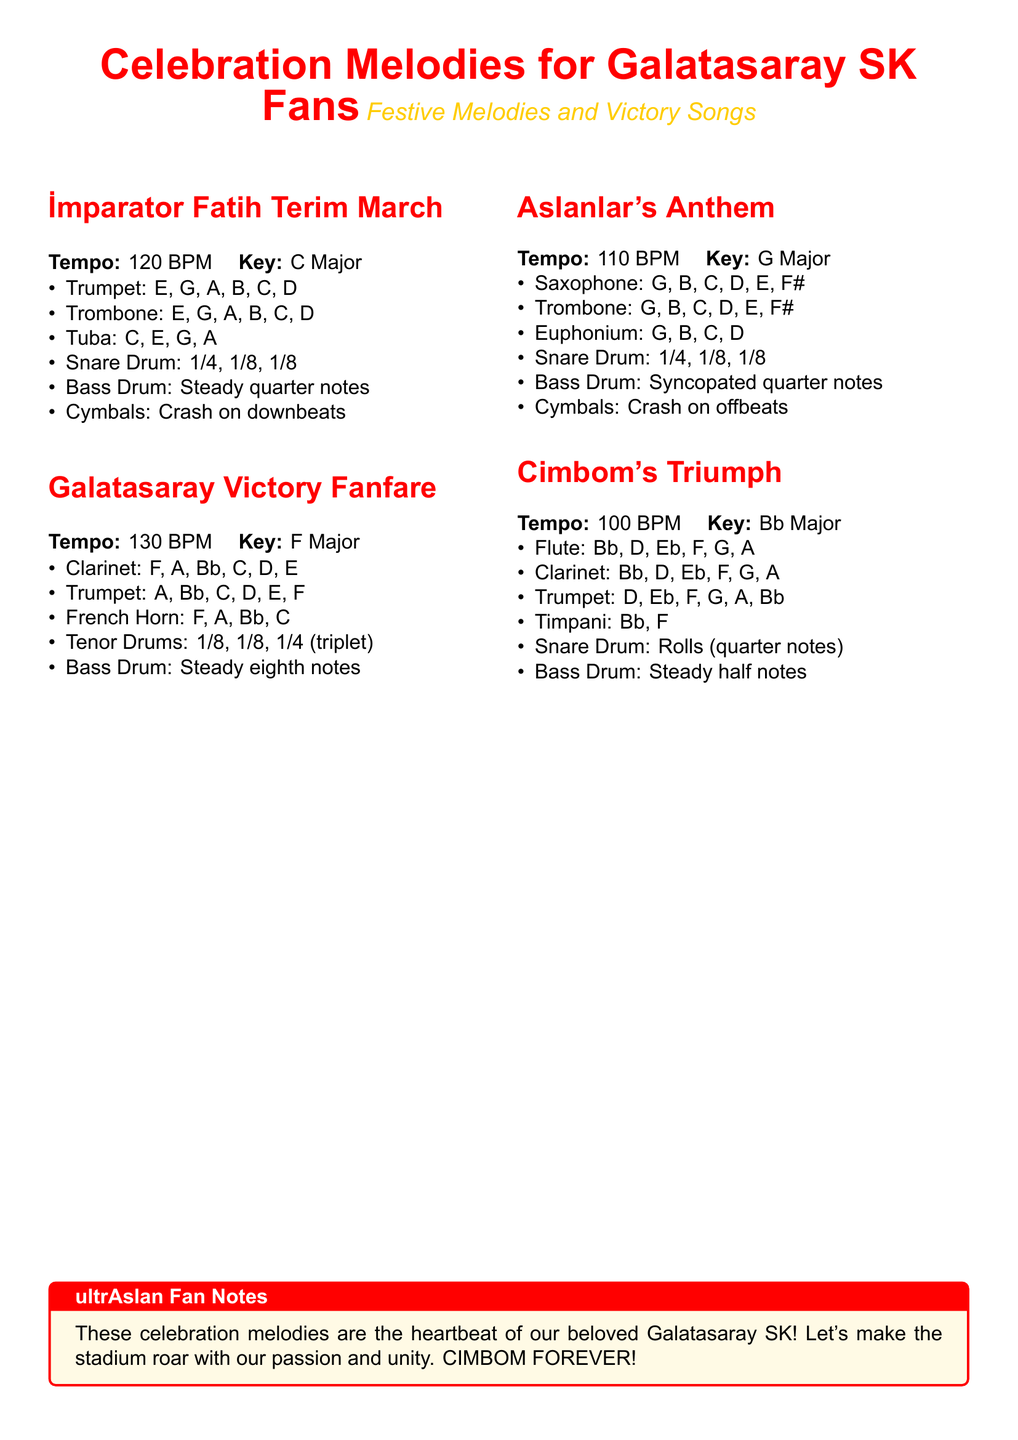What is the title of the document? The title is prominently displayed at the beginning of the document, stating the theme of the sheet music.
Answer: Celebration Melodies for Galatasaray SK Fans What is the tempo of the İmparator Fatih Terim March? The tempo is mentioned directly below the title in the document.
Answer: 120 BPM What key is the Galatasaray Victory Fanfare arranged in? The key is specified in the arrangement details for this particular piece.
Answer: F Major How many measures does the Snare Drum part have in Aslanlar's Anthem? The document lists the rhythm patterns for the Snare Drum, which indicates its measures.
Answer: 1/4, 1/8, 1/8 What instrument plays the steady half notes in Cimbom's Triumph? The specific details of each instrument's notes in the arrangement indicate which one plays these notes.
Answer: Bass Drum What color represents Galatasaray's theme in this document? The document uses specific colors to emphasize the Galatasaray theme throughout, including in the title.
Answer: Red and Yellow What does the tcolorbox in the document signify? The tcolorbox contains notes or commentary related to the document's theme, highlighting an emotional connection.
Answer: ultrAslan Fan Notes What is the key of Aslanlar's Anthem? The key is directly mentioned in the arrangement section of this melody.
Answer: G Major 